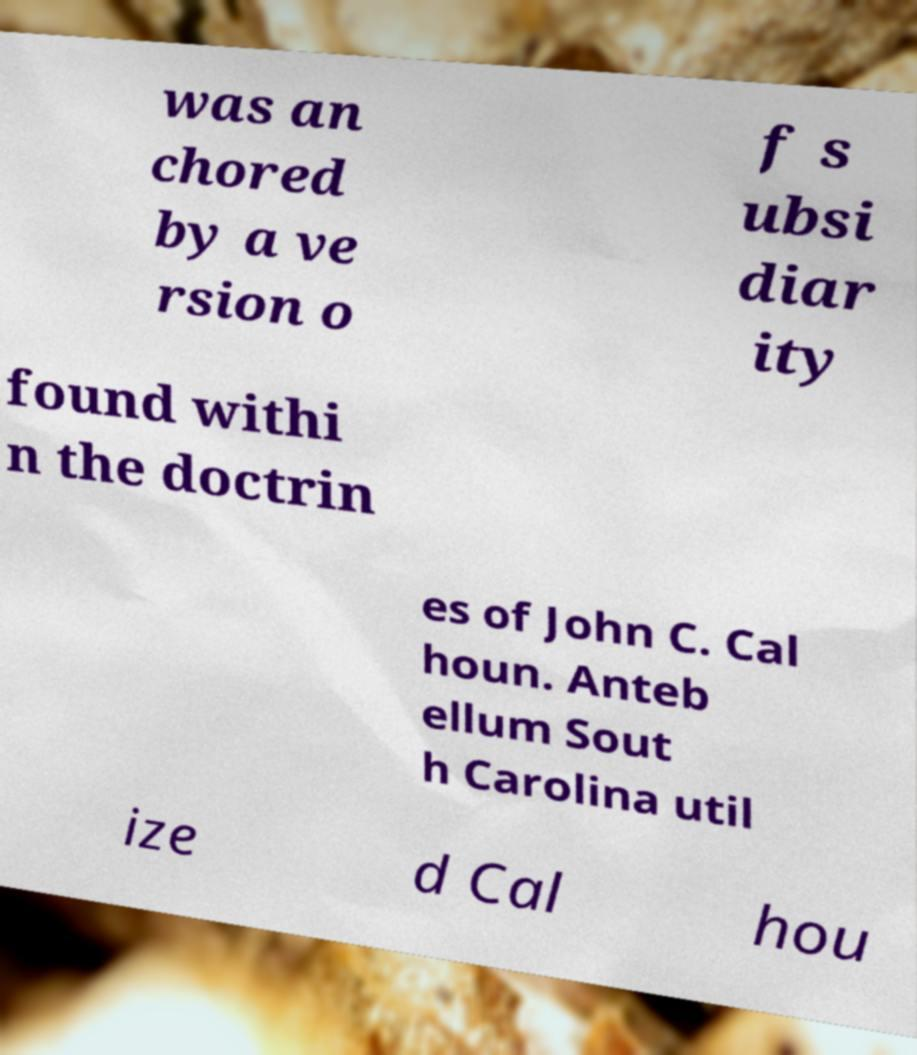What messages or text are displayed in this image? I need them in a readable, typed format. was an chored by a ve rsion o f s ubsi diar ity found withi n the doctrin es of John C. Cal houn. Anteb ellum Sout h Carolina util ize d Cal hou 